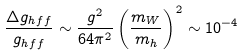<formula> <loc_0><loc_0><loc_500><loc_500>\frac { \Delta g _ { h f f } } { g _ { h f f } } \sim \frac { g ^ { 2 } } { 6 4 \pi ^ { 2 } } \left ( \frac { m _ { W } } { m _ { h } } \right ) ^ { 2 } \sim 1 0 ^ { - 4 }</formula> 